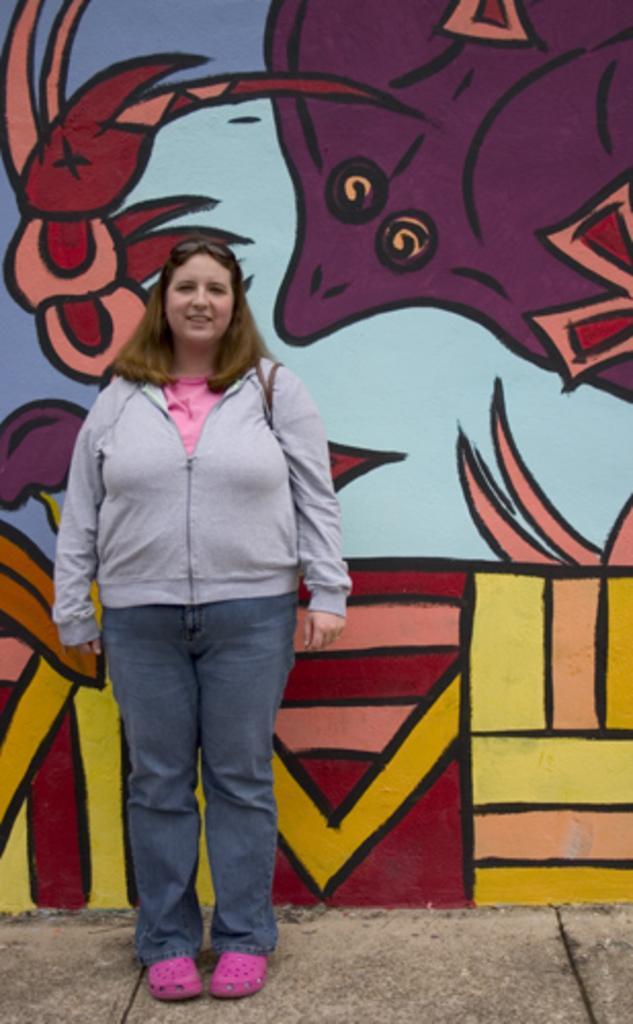In one or two sentences, can you explain what this image depicts? In-front of this wall a person is standing and she wore jacket. Painting is on the wall. 